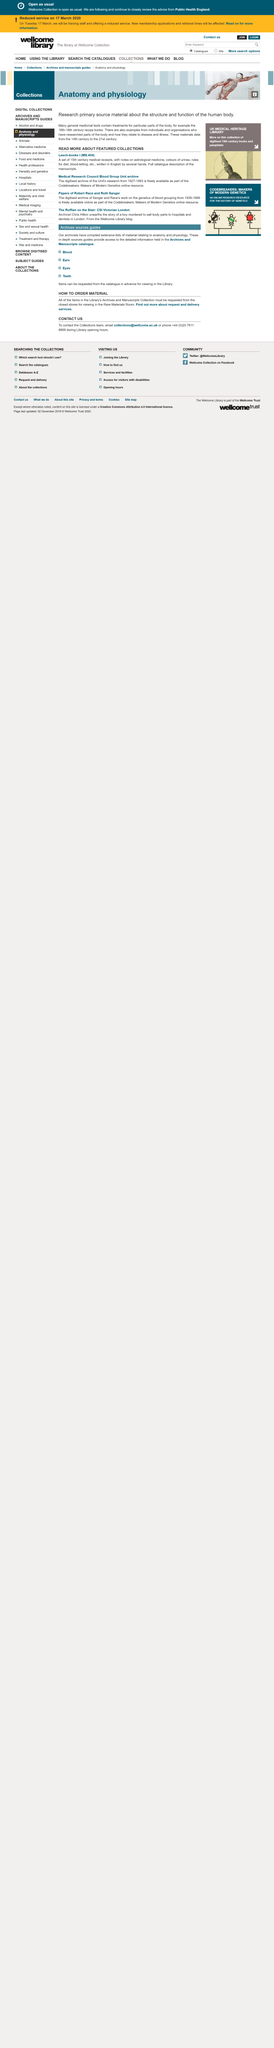Specify some key components in this picture. The Leech-books were from the 15th century. The two featured collections that are being showcased are Leech-books I (MS.404) and the Medical Research Council Blood Group Unit archive. The Leech-books I (MS.404) is the older of the two featured collections. 